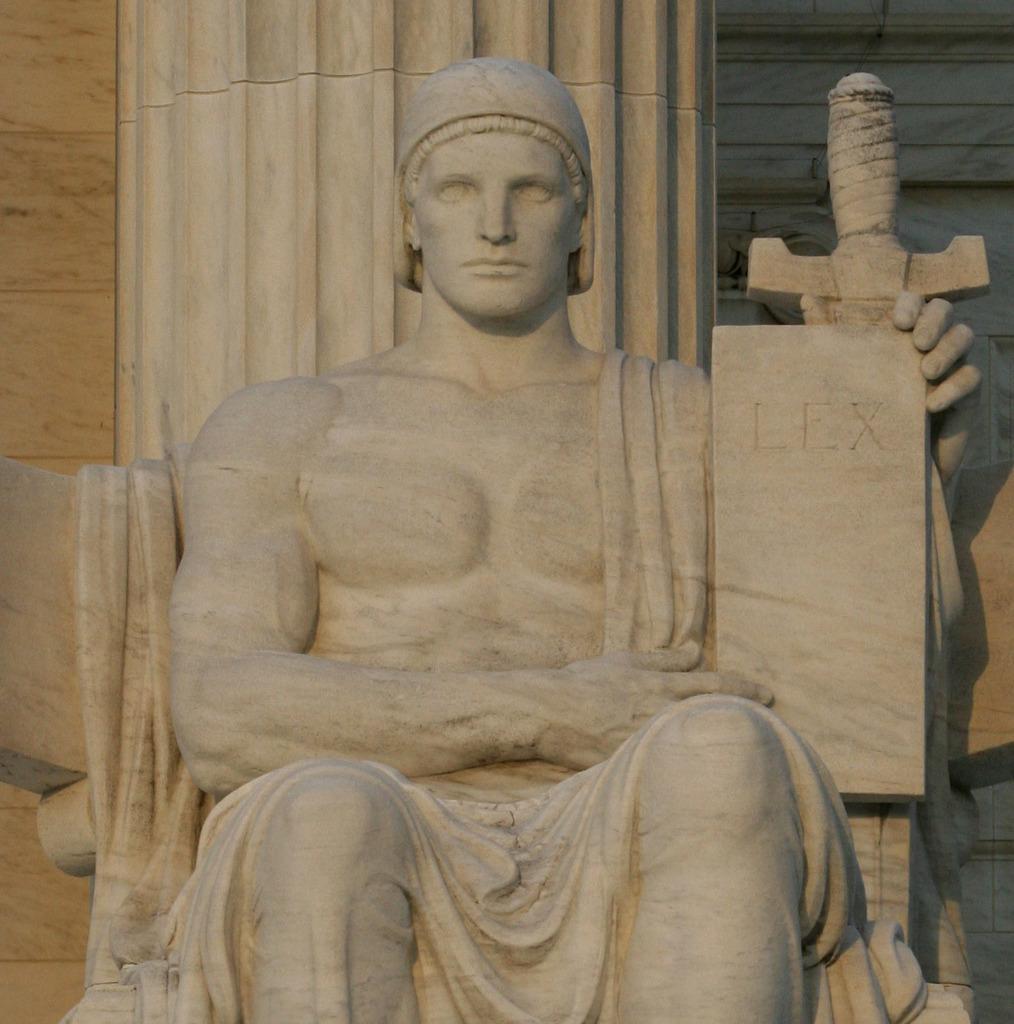Describe this image in one or two sentences. In the center of the image there is a statue of a person. In the background of the image there is wall. 